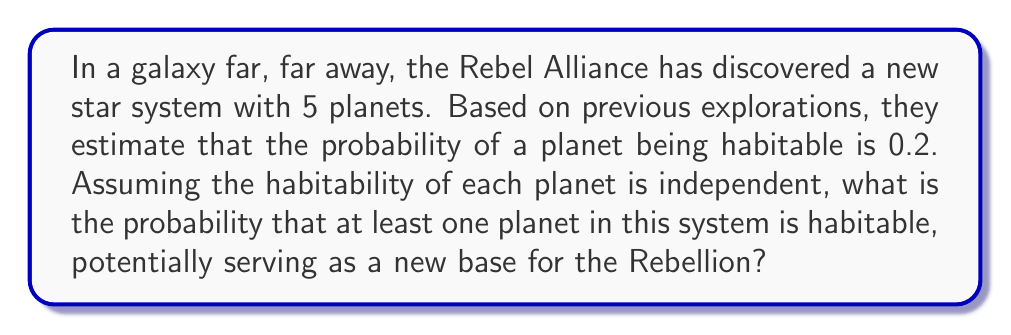Provide a solution to this math problem. Let's approach this step-by-step using Bayesian probability:

1) First, let's define our events:
   $H$ = at least one planet is habitable
   $\bar{H}$ = no planet is habitable

2) We're looking for $P(H)$, but it's easier to calculate $P(\bar{H})$ and then use the complement rule.

3) For no planets to be habitable, all 5 must be uninhabitable. The probability of a planet being uninhabitable is $1 - 0.2 = 0.8$.

4) Since the events are independent, we multiply the probabilities:

   $P(\bar{H}) = 0.8^5 = 0.32768$

5) Now we can use the complement rule:

   $P(H) = 1 - P(\bar{H}) = 1 - 0.32768 = 0.67232$

6) Therefore, the probability of at least one planet being habitable is approximately 0.67232 or about 67.23%.

This can also be calculated using the binomial probability formula:

$$P(X \geq 1) = 1 - P(X = 0) = 1 - \binom{5}{0}(0.2)^0(0.8)^5 = 1 - 0.32768 = 0.67232$$

Where $X$ is the number of habitable planets.
Answer: The probability of finding at least one habitable planet in the newly discovered star system is approximately 0.67232 or 67.23%. 